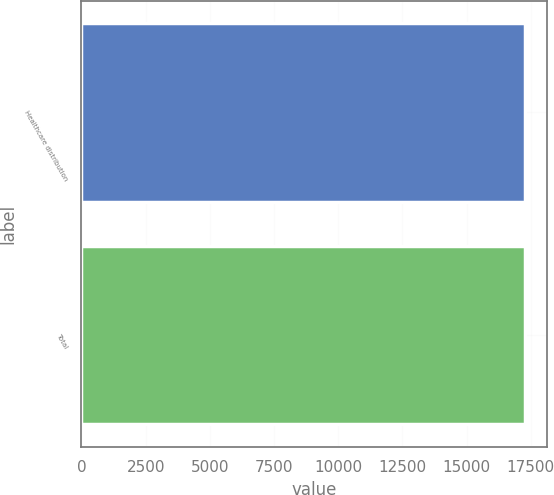Convert chart to OTSL. <chart><loc_0><loc_0><loc_500><loc_500><bar_chart><fcel>Healthcare distribution<fcel>Total<nl><fcel>17252<fcel>17260<nl></chart> 